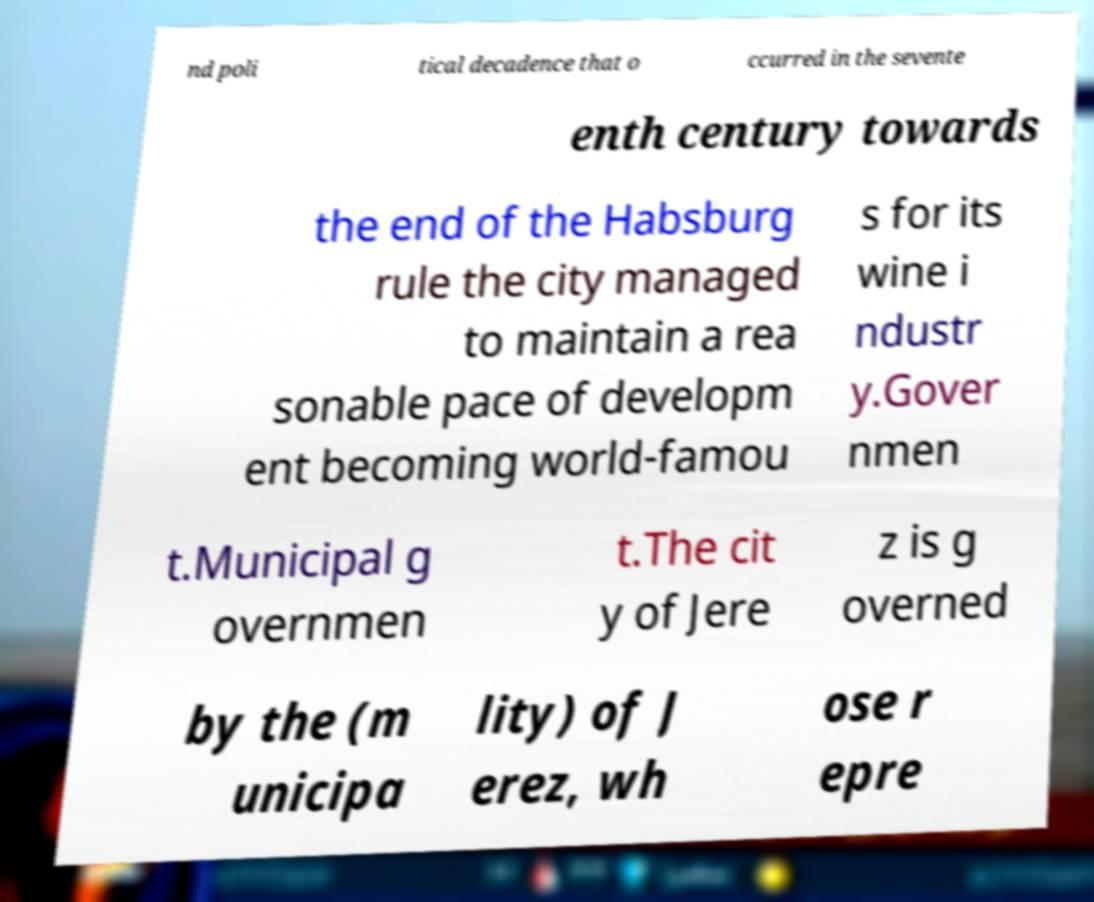I need the written content from this picture converted into text. Can you do that? nd poli tical decadence that o ccurred in the sevente enth century towards the end of the Habsburg rule the city managed to maintain a rea sonable pace of developm ent becoming world-famou s for its wine i ndustr y.Gover nmen t.Municipal g overnmen t.The cit y of Jere z is g overned by the (m unicipa lity) of J erez, wh ose r epre 